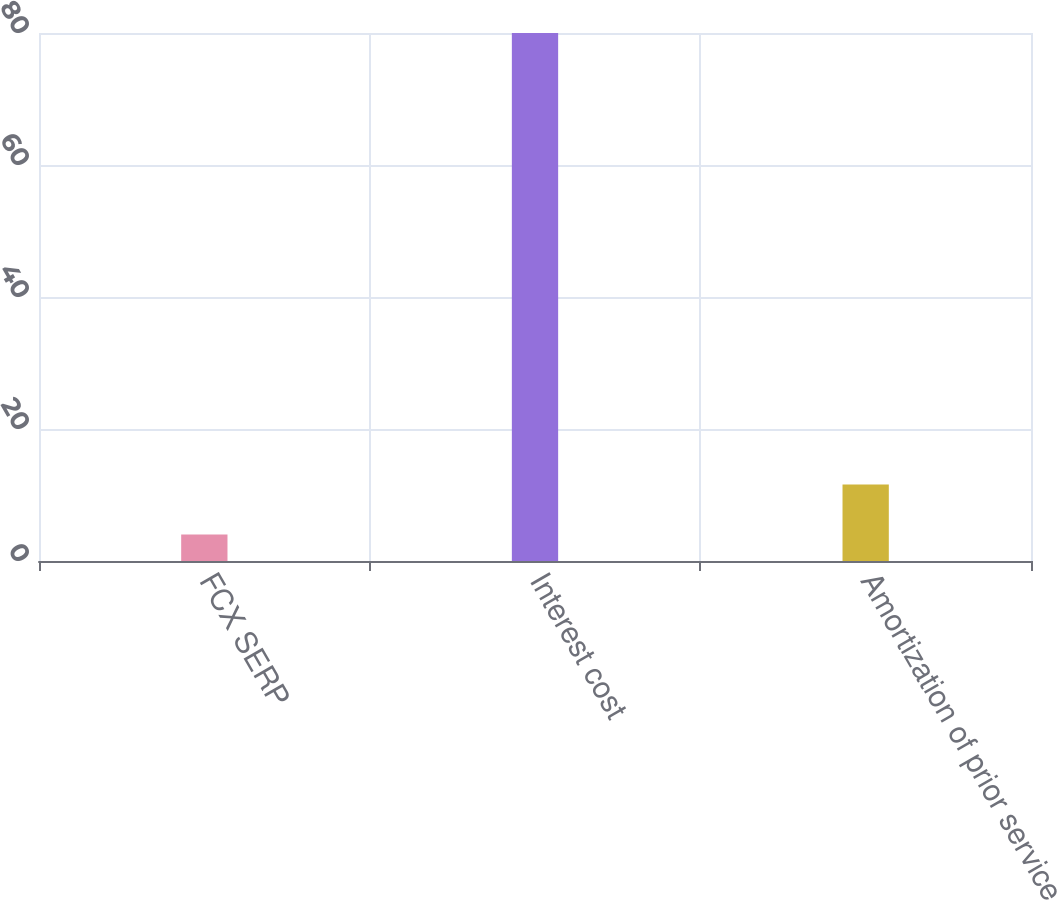Convert chart. <chart><loc_0><loc_0><loc_500><loc_500><bar_chart><fcel>FCX SERP<fcel>Interest cost<fcel>Amortization of prior service<nl><fcel>4<fcel>80<fcel>11.6<nl></chart> 